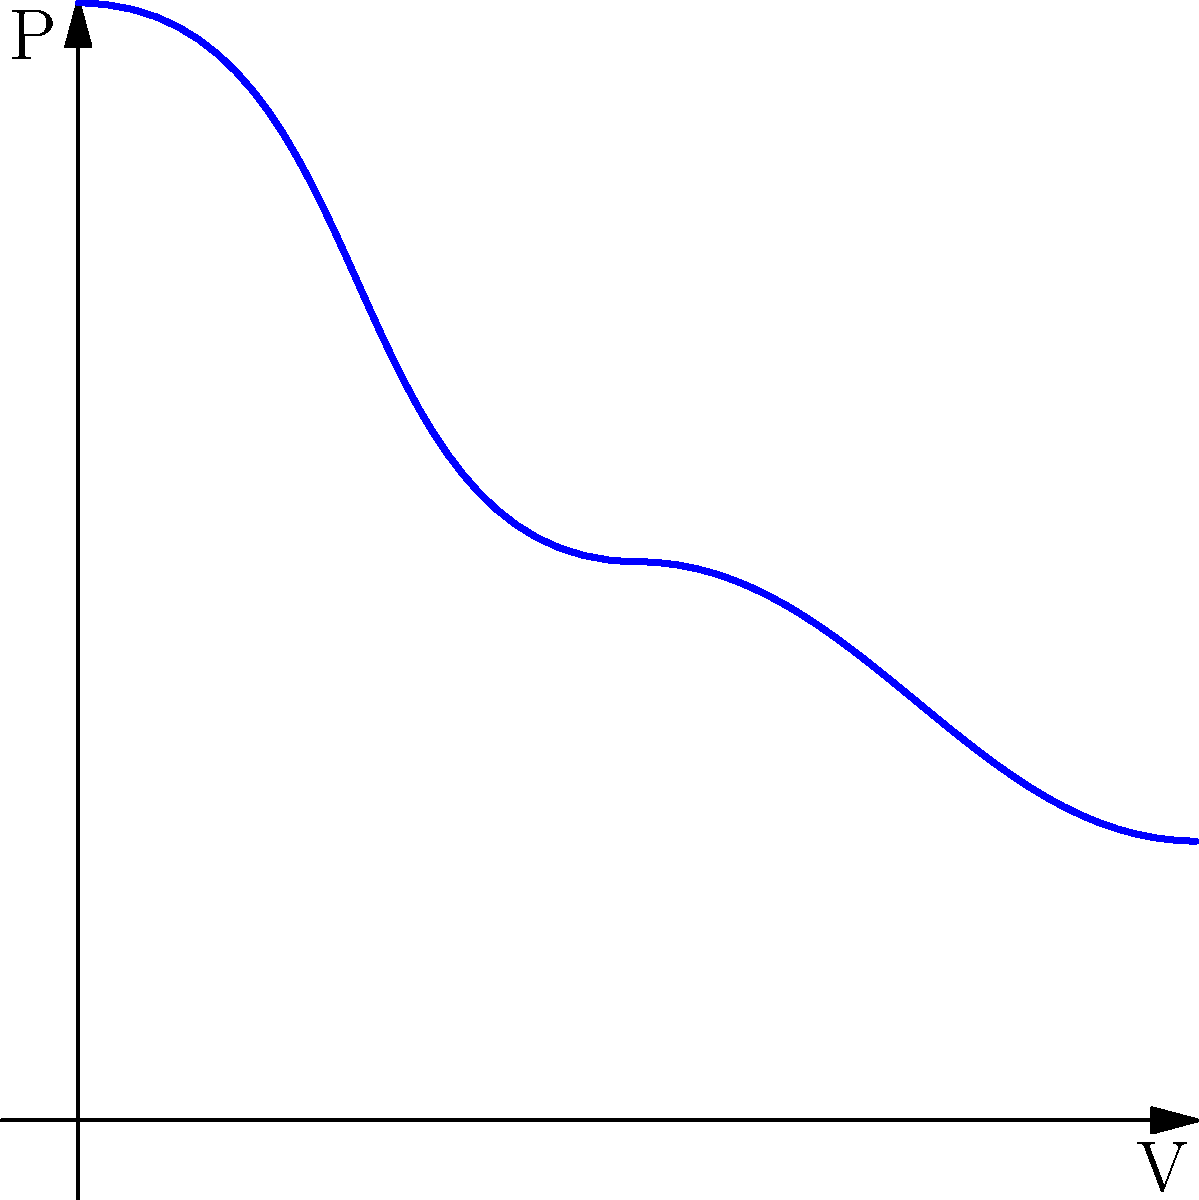In the pressure-volume diagram of an ideal gas undergoing a process in a piston-cylinder arrangement, shown above, what type of thermodynamic process is represented by the curve from point 1 to point 3? To determine the type of thermodynamic process, we need to analyze the relationship between pressure (P) and volume (V) in the given diagram:

1. Observe that the curve is not a straight line, which immediately rules out isobaric (constant pressure) and isochoric (constant volume) processes.

2. The curve shows a decrease in pressure as volume increases, which is characteristic of expansion processes.

3. The shape of the curve is not linear, which eliminates isothermal processes (PV = constant, which would result in a hyperbola).

4. The curve's shape resembles that of an adiabatic process, where $PV^\gamma = constant$, and $\gamma$ is the ratio of specific heats.

5. In an adiabatic process, there is no heat transfer with the surroundings, and the temperature changes as the gas expands or compresses.

6. The steeper initial slope of the curve (compared to an isothermal process) is consistent with an adiabatic expansion, where the temperature decreases during the process.

Given the context of a tech entrepreneur familiar with microservices architecture, we can draw a parallel: just as microservices allow for independent scaling and optimization of system components, an adiabatic process represents an optimized thermodynamic process where energy is conserved within the system without external heat transfer.
Answer: Adiabatic process 